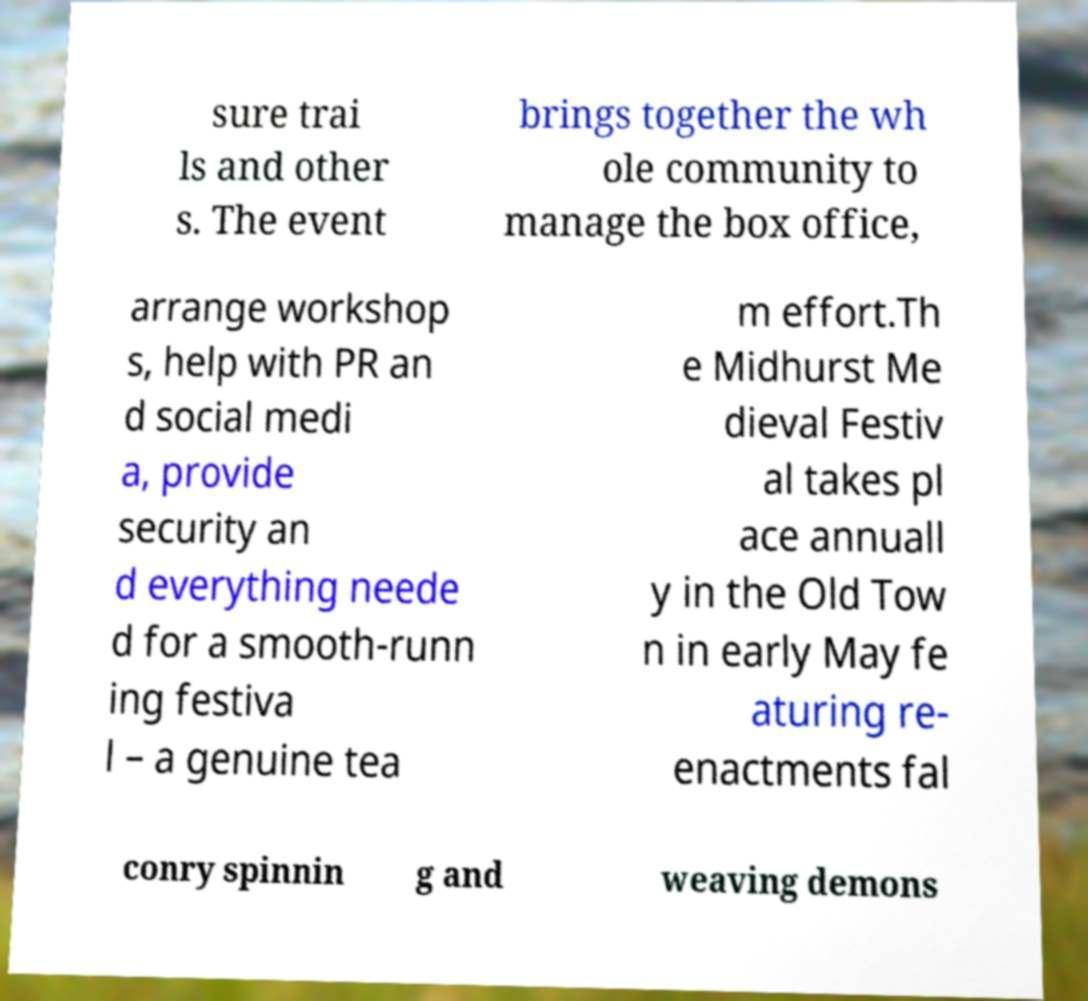Can you accurately transcribe the text from the provided image for me? sure trai ls and other s. The event brings together the wh ole community to manage the box office, arrange workshop s, help with PR an d social medi a, provide security an d everything neede d for a smooth-runn ing festiva l – a genuine tea m effort.Th e Midhurst Me dieval Festiv al takes pl ace annuall y in the Old Tow n in early May fe aturing re- enactments fal conry spinnin g and weaving demons 